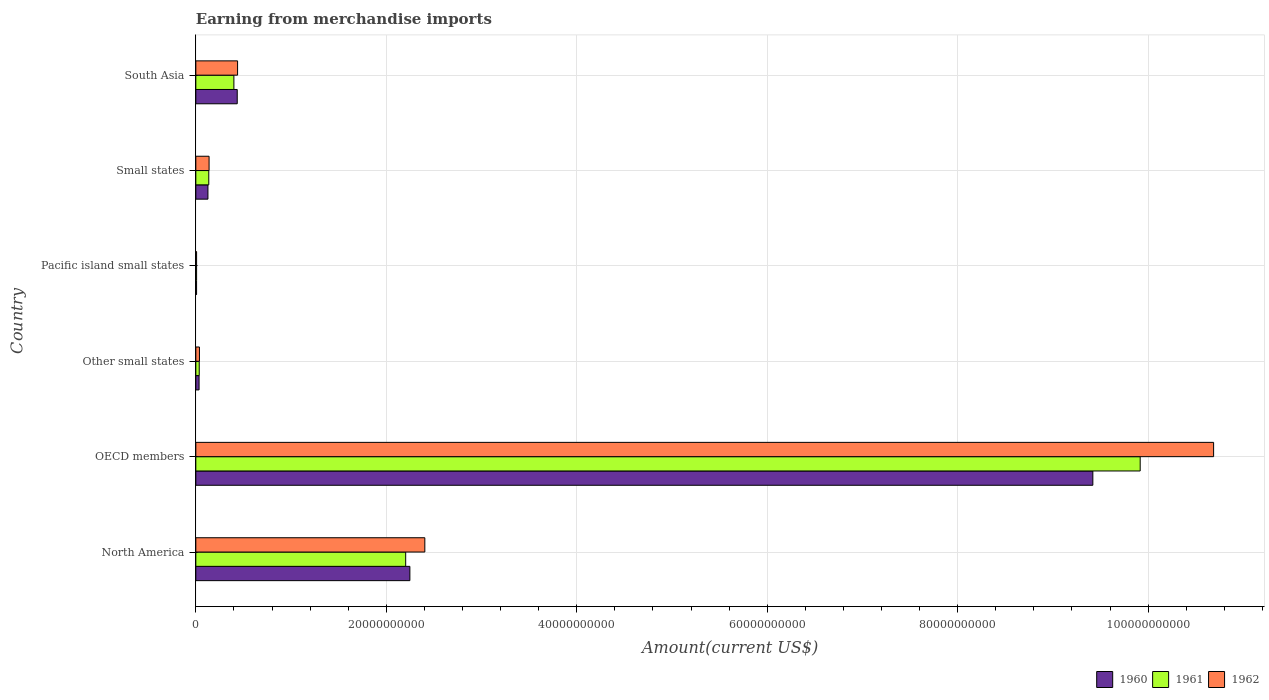How many groups of bars are there?
Keep it short and to the point. 6. Are the number of bars per tick equal to the number of legend labels?
Provide a short and direct response. Yes. How many bars are there on the 5th tick from the top?
Ensure brevity in your answer.  3. How many bars are there on the 5th tick from the bottom?
Keep it short and to the point. 3. In how many cases, is the number of bars for a given country not equal to the number of legend labels?
Offer a very short reply. 0. What is the amount earned from merchandise imports in 1961 in Other small states?
Your response must be concise. 3.58e+08. Across all countries, what is the maximum amount earned from merchandise imports in 1960?
Offer a terse response. 9.42e+1. Across all countries, what is the minimum amount earned from merchandise imports in 1961?
Ensure brevity in your answer.  8.07e+07. In which country was the amount earned from merchandise imports in 1960 minimum?
Your answer should be very brief. Pacific island small states. What is the total amount earned from merchandise imports in 1962 in the graph?
Your answer should be very brief. 1.37e+11. What is the difference between the amount earned from merchandise imports in 1961 in OECD members and that in Other small states?
Provide a succinct answer. 9.88e+1. What is the difference between the amount earned from merchandise imports in 1962 in North America and the amount earned from merchandise imports in 1960 in OECD members?
Your answer should be very brief. -7.01e+1. What is the average amount earned from merchandise imports in 1960 per country?
Ensure brevity in your answer.  2.05e+1. What is the difference between the amount earned from merchandise imports in 1962 and amount earned from merchandise imports in 1961 in North America?
Give a very brief answer. 2.01e+09. In how many countries, is the amount earned from merchandise imports in 1961 greater than 4000000000 US$?
Provide a succinct answer. 2. What is the ratio of the amount earned from merchandise imports in 1962 in Other small states to that in Pacific island small states?
Make the answer very short. 4.69. What is the difference between the highest and the second highest amount earned from merchandise imports in 1960?
Your answer should be compact. 7.17e+1. What is the difference between the highest and the lowest amount earned from merchandise imports in 1961?
Offer a terse response. 9.91e+1. What does the 3rd bar from the top in North America represents?
Your response must be concise. 1960. How many countries are there in the graph?
Your answer should be very brief. 6. What is the difference between two consecutive major ticks on the X-axis?
Your answer should be compact. 2.00e+1. Are the values on the major ticks of X-axis written in scientific E-notation?
Your answer should be compact. No. Does the graph contain any zero values?
Ensure brevity in your answer.  No. Does the graph contain grids?
Provide a succinct answer. Yes. Where does the legend appear in the graph?
Offer a terse response. Bottom right. How are the legend labels stacked?
Your answer should be very brief. Horizontal. What is the title of the graph?
Offer a terse response. Earning from merchandise imports. What is the label or title of the X-axis?
Provide a short and direct response. Amount(current US$). What is the Amount(current US$) of 1960 in North America?
Give a very brief answer. 2.25e+1. What is the Amount(current US$) in 1961 in North America?
Provide a succinct answer. 2.20e+1. What is the Amount(current US$) of 1962 in North America?
Make the answer very short. 2.40e+1. What is the Amount(current US$) of 1960 in OECD members?
Make the answer very short. 9.42e+1. What is the Amount(current US$) in 1961 in OECD members?
Your response must be concise. 9.92e+1. What is the Amount(current US$) in 1962 in OECD members?
Your response must be concise. 1.07e+11. What is the Amount(current US$) of 1960 in Other small states?
Provide a succinct answer. 3.42e+08. What is the Amount(current US$) of 1961 in Other small states?
Your answer should be very brief. 3.58e+08. What is the Amount(current US$) in 1962 in Other small states?
Provide a short and direct response. 3.80e+08. What is the Amount(current US$) in 1960 in Pacific island small states?
Give a very brief answer. 7.79e+07. What is the Amount(current US$) in 1961 in Pacific island small states?
Provide a short and direct response. 8.07e+07. What is the Amount(current US$) of 1962 in Pacific island small states?
Give a very brief answer. 8.11e+07. What is the Amount(current US$) of 1960 in Small states?
Provide a short and direct response. 1.27e+09. What is the Amount(current US$) in 1961 in Small states?
Keep it short and to the point. 1.36e+09. What is the Amount(current US$) of 1962 in Small states?
Your answer should be very brief. 1.39e+09. What is the Amount(current US$) of 1960 in South Asia?
Offer a very short reply. 4.35e+09. What is the Amount(current US$) of 1961 in South Asia?
Ensure brevity in your answer.  4.00e+09. What is the Amount(current US$) of 1962 in South Asia?
Keep it short and to the point. 4.38e+09. Across all countries, what is the maximum Amount(current US$) in 1960?
Keep it short and to the point. 9.42e+1. Across all countries, what is the maximum Amount(current US$) of 1961?
Offer a very short reply. 9.92e+1. Across all countries, what is the maximum Amount(current US$) in 1962?
Provide a succinct answer. 1.07e+11. Across all countries, what is the minimum Amount(current US$) of 1960?
Make the answer very short. 7.79e+07. Across all countries, what is the minimum Amount(current US$) of 1961?
Provide a succinct answer. 8.07e+07. Across all countries, what is the minimum Amount(current US$) of 1962?
Your response must be concise. 8.11e+07. What is the total Amount(current US$) of 1960 in the graph?
Offer a terse response. 1.23e+11. What is the total Amount(current US$) of 1961 in the graph?
Offer a very short reply. 1.27e+11. What is the total Amount(current US$) of 1962 in the graph?
Your answer should be very brief. 1.37e+11. What is the difference between the Amount(current US$) of 1960 in North America and that in OECD members?
Offer a terse response. -7.17e+1. What is the difference between the Amount(current US$) of 1961 in North America and that in OECD members?
Provide a succinct answer. -7.71e+1. What is the difference between the Amount(current US$) of 1962 in North America and that in OECD members?
Your response must be concise. -8.28e+1. What is the difference between the Amount(current US$) of 1960 in North America and that in Other small states?
Your answer should be compact. 2.21e+1. What is the difference between the Amount(current US$) in 1961 in North America and that in Other small states?
Ensure brevity in your answer.  2.17e+1. What is the difference between the Amount(current US$) of 1962 in North America and that in Other small states?
Provide a succinct answer. 2.37e+1. What is the difference between the Amount(current US$) of 1960 in North America and that in Pacific island small states?
Offer a terse response. 2.24e+1. What is the difference between the Amount(current US$) in 1961 in North America and that in Pacific island small states?
Your answer should be very brief. 2.20e+1. What is the difference between the Amount(current US$) of 1962 in North America and that in Pacific island small states?
Provide a succinct answer. 2.40e+1. What is the difference between the Amount(current US$) in 1960 in North America and that in Small states?
Your response must be concise. 2.12e+1. What is the difference between the Amount(current US$) in 1961 in North America and that in Small states?
Offer a terse response. 2.07e+1. What is the difference between the Amount(current US$) in 1962 in North America and that in Small states?
Provide a succinct answer. 2.27e+1. What is the difference between the Amount(current US$) of 1960 in North America and that in South Asia?
Provide a succinct answer. 1.81e+1. What is the difference between the Amount(current US$) of 1961 in North America and that in South Asia?
Your answer should be compact. 1.80e+1. What is the difference between the Amount(current US$) in 1962 in North America and that in South Asia?
Provide a succinct answer. 1.97e+1. What is the difference between the Amount(current US$) in 1960 in OECD members and that in Other small states?
Offer a terse response. 9.38e+1. What is the difference between the Amount(current US$) in 1961 in OECD members and that in Other small states?
Offer a very short reply. 9.88e+1. What is the difference between the Amount(current US$) in 1962 in OECD members and that in Other small states?
Ensure brevity in your answer.  1.06e+11. What is the difference between the Amount(current US$) of 1960 in OECD members and that in Pacific island small states?
Ensure brevity in your answer.  9.41e+1. What is the difference between the Amount(current US$) in 1961 in OECD members and that in Pacific island small states?
Give a very brief answer. 9.91e+1. What is the difference between the Amount(current US$) in 1962 in OECD members and that in Pacific island small states?
Offer a terse response. 1.07e+11. What is the difference between the Amount(current US$) in 1960 in OECD members and that in Small states?
Provide a short and direct response. 9.29e+1. What is the difference between the Amount(current US$) in 1961 in OECD members and that in Small states?
Offer a terse response. 9.78e+1. What is the difference between the Amount(current US$) of 1962 in OECD members and that in Small states?
Your response must be concise. 1.05e+11. What is the difference between the Amount(current US$) in 1960 in OECD members and that in South Asia?
Keep it short and to the point. 8.98e+1. What is the difference between the Amount(current US$) in 1961 in OECD members and that in South Asia?
Your answer should be very brief. 9.52e+1. What is the difference between the Amount(current US$) in 1962 in OECD members and that in South Asia?
Provide a succinct answer. 1.02e+11. What is the difference between the Amount(current US$) in 1960 in Other small states and that in Pacific island small states?
Provide a succinct answer. 2.64e+08. What is the difference between the Amount(current US$) of 1961 in Other small states and that in Pacific island small states?
Your answer should be very brief. 2.77e+08. What is the difference between the Amount(current US$) of 1962 in Other small states and that in Pacific island small states?
Keep it short and to the point. 2.99e+08. What is the difference between the Amount(current US$) of 1960 in Other small states and that in Small states?
Your answer should be very brief. -9.30e+08. What is the difference between the Amount(current US$) in 1961 in Other small states and that in Small states?
Provide a short and direct response. -1.00e+09. What is the difference between the Amount(current US$) of 1962 in Other small states and that in Small states?
Provide a succinct answer. -1.01e+09. What is the difference between the Amount(current US$) of 1960 in Other small states and that in South Asia?
Your response must be concise. -4.01e+09. What is the difference between the Amount(current US$) in 1961 in Other small states and that in South Asia?
Make the answer very short. -3.64e+09. What is the difference between the Amount(current US$) in 1962 in Other small states and that in South Asia?
Provide a succinct answer. -4.00e+09. What is the difference between the Amount(current US$) of 1960 in Pacific island small states and that in Small states?
Offer a very short reply. -1.19e+09. What is the difference between the Amount(current US$) of 1961 in Pacific island small states and that in Small states?
Your answer should be compact. -1.28e+09. What is the difference between the Amount(current US$) in 1962 in Pacific island small states and that in Small states?
Offer a terse response. -1.31e+09. What is the difference between the Amount(current US$) in 1960 in Pacific island small states and that in South Asia?
Your answer should be very brief. -4.27e+09. What is the difference between the Amount(current US$) of 1961 in Pacific island small states and that in South Asia?
Provide a succinct answer. -3.92e+09. What is the difference between the Amount(current US$) in 1962 in Pacific island small states and that in South Asia?
Your answer should be compact. -4.30e+09. What is the difference between the Amount(current US$) of 1960 in Small states and that in South Asia?
Ensure brevity in your answer.  -3.08e+09. What is the difference between the Amount(current US$) of 1961 in Small states and that in South Asia?
Offer a terse response. -2.64e+09. What is the difference between the Amount(current US$) in 1962 in Small states and that in South Asia?
Offer a terse response. -2.99e+09. What is the difference between the Amount(current US$) of 1960 in North America and the Amount(current US$) of 1961 in OECD members?
Your answer should be compact. -7.67e+1. What is the difference between the Amount(current US$) in 1960 in North America and the Amount(current US$) in 1962 in OECD members?
Give a very brief answer. -8.44e+1. What is the difference between the Amount(current US$) of 1961 in North America and the Amount(current US$) of 1962 in OECD members?
Offer a terse response. -8.48e+1. What is the difference between the Amount(current US$) in 1960 in North America and the Amount(current US$) in 1961 in Other small states?
Provide a short and direct response. 2.21e+1. What is the difference between the Amount(current US$) in 1960 in North America and the Amount(current US$) in 1962 in Other small states?
Your answer should be compact. 2.21e+1. What is the difference between the Amount(current US$) in 1961 in North America and the Amount(current US$) in 1962 in Other small states?
Give a very brief answer. 2.17e+1. What is the difference between the Amount(current US$) of 1960 in North America and the Amount(current US$) of 1961 in Pacific island small states?
Your answer should be compact. 2.24e+1. What is the difference between the Amount(current US$) in 1960 in North America and the Amount(current US$) in 1962 in Pacific island small states?
Provide a succinct answer. 2.24e+1. What is the difference between the Amount(current US$) in 1961 in North America and the Amount(current US$) in 1962 in Pacific island small states?
Your answer should be compact. 2.20e+1. What is the difference between the Amount(current US$) of 1960 in North America and the Amount(current US$) of 1961 in Small states?
Your answer should be very brief. 2.11e+1. What is the difference between the Amount(current US$) of 1960 in North America and the Amount(current US$) of 1962 in Small states?
Ensure brevity in your answer.  2.11e+1. What is the difference between the Amount(current US$) of 1961 in North America and the Amount(current US$) of 1962 in Small states?
Your answer should be compact. 2.06e+1. What is the difference between the Amount(current US$) of 1960 in North America and the Amount(current US$) of 1961 in South Asia?
Provide a short and direct response. 1.85e+1. What is the difference between the Amount(current US$) of 1960 in North America and the Amount(current US$) of 1962 in South Asia?
Offer a very short reply. 1.81e+1. What is the difference between the Amount(current US$) of 1961 in North America and the Amount(current US$) of 1962 in South Asia?
Your answer should be very brief. 1.77e+1. What is the difference between the Amount(current US$) of 1960 in OECD members and the Amount(current US$) of 1961 in Other small states?
Give a very brief answer. 9.38e+1. What is the difference between the Amount(current US$) of 1960 in OECD members and the Amount(current US$) of 1962 in Other small states?
Provide a short and direct response. 9.38e+1. What is the difference between the Amount(current US$) in 1961 in OECD members and the Amount(current US$) in 1962 in Other small states?
Ensure brevity in your answer.  9.88e+1. What is the difference between the Amount(current US$) of 1960 in OECD members and the Amount(current US$) of 1961 in Pacific island small states?
Provide a short and direct response. 9.41e+1. What is the difference between the Amount(current US$) in 1960 in OECD members and the Amount(current US$) in 1962 in Pacific island small states?
Your response must be concise. 9.41e+1. What is the difference between the Amount(current US$) of 1961 in OECD members and the Amount(current US$) of 1962 in Pacific island small states?
Offer a very short reply. 9.91e+1. What is the difference between the Amount(current US$) of 1960 in OECD members and the Amount(current US$) of 1961 in Small states?
Provide a short and direct response. 9.28e+1. What is the difference between the Amount(current US$) of 1960 in OECD members and the Amount(current US$) of 1962 in Small states?
Make the answer very short. 9.28e+1. What is the difference between the Amount(current US$) of 1961 in OECD members and the Amount(current US$) of 1962 in Small states?
Offer a terse response. 9.78e+1. What is the difference between the Amount(current US$) in 1960 in OECD members and the Amount(current US$) in 1961 in South Asia?
Your answer should be compact. 9.02e+1. What is the difference between the Amount(current US$) in 1960 in OECD members and the Amount(current US$) in 1962 in South Asia?
Keep it short and to the point. 8.98e+1. What is the difference between the Amount(current US$) of 1961 in OECD members and the Amount(current US$) of 1962 in South Asia?
Your answer should be very brief. 9.48e+1. What is the difference between the Amount(current US$) of 1960 in Other small states and the Amount(current US$) of 1961 in Pacific island small states?
Your response must be concise. 2.61e+08. What is the difference between the Amount(current US$) of 1960 in Other small states and the Amount(current US$) of 1962 in Pacific island small states?
Ensure brevity in your answer.  2.61e+08. What is the difference between the Amount(current US$) of 1961 in Other small states and the Amount(current US$) of 1962 in Pacific island small states?
Give a very brief answer. 2.77e+08. What is the difference between the Amount(current US$) in 1960 in Other small states and the Amount(current US$) in 1961 in Small states?
Your answer should be very brief. -1.02e+09. What is the difference between the Amount(current US$) in 1960 in Other small states and the Amount(current US$) in 1962 in Small states?
Your answer should be compact. -1.05e+09. What is the difference between the Amount(current US$) of 1961 in Other small states and the Amount(current US$) of 1962 in Small states?
Ensure brevity in your answer.  -1.03e+09. What is the difference between the Amount(current US$) of 1960 in Other small states and the Amount(current US$) of 1961 in South Asia?
Offer a very short reply. -3.65e+09. What is the difference between the Amount(current US$) of 1960 in Other small states and the Amount(current US$) of 1962 in South Asia?
Provide a short and direct response. -4.04e+09. What is the difference between the Amount(current US$) in 1961 in Other small states and the Amount(current US$) in 1962 in South Asia?
Give a very brief answer. -4.03e+09. What is the difference between the Amount(current US$) of 1960 in Pacific island small states and the Amount(current US$) of 1961 in Small states?
Provide a succinct answer. -1.28e+09. What is the difference between the Amount(current US$) in 1960 in Pacific island small states and the Amount(current US$) in 1962 in Small states?
Offer a terse response. -1.31e+09. What is the difference between the Amount(current US$) in 1961 in Pacific island small states and the Amount(current US$) in 1962 in Small states?
Give a very brief answer. -1.31e+09. What is the difference between the Amount(current US$) of 1960 in Pacific island small states and the Amount(current US$) of 1961 in South Asia?
Keep it short and to the point. -3.92e+09. What is the difference between the Amount(current US$) of 1960 in Pacific island small states and the Amount(current US$) of 1962 in South Asia?
Provide a succinct answer. -4.31e+09. What is the difference between the Amount(current US$) of 1961 in Pacific island small states and the Amount(current US$) of 1962 in South Asia?
Your answer should be very brief. -4.30e+09. What is the difference between the Amount(current US$) in 1960 in Small states and the Amount(current US$) in 1961 in South Asia?
Ensure brevity in your answer.  -2.72e+09. What is the difference between the Amount(current US$) of 1960 in Small states and the Amount(current US$) of 1962 in South Asia?
Your answer should be compact. -3.11e+09. What is the difference between the Amount(current US$) in 1961 in Small states and the Amount(current US$) in 1962 in South Asia?
Give a very brief answer. -3.02e+09. What is the average Amount(current US$) of 1960 per country?
Your response must be concise. 2.05e+1. What is the average Amount(current US$) in 1961 per country?
Make the answer very short. 2.12e+1. What is the average Amount(current US$) of 1962 per country?
Provide a succinct answer. 2.29e+1. What is the difference between the Amount(current US$) in 1960 and Amount(current US$) in 1961 in North America?
Provide a succinct answer. 4.40e+08. What is the difference between the Amount(current US$) in 1960 and Amount(current US$) in 1962 in North America?
Keep it short and to the point. -1.57e+09. What is the difference between the Amount(current US$) of 1961 and Amount(current US$) of 1962 in North America?
Provide a succinct answer. -2.01e+09. What is the difference between the Amount(current US$) in 1960 and Amount(current US$) in 1961 in OECD members?
Ensure brevity in your answer.  -4.97e+09. What is the difference between the Amount(current US$) of 1960 and Amount(current US$) of 1962 in OECD members?
Keep it short and to the point. -1.27e+1. What is the difference between the Amount(current US$) of 1961 and Amount(current US$) of 1962 in OECD members?
Your answer should be compact. -7.71e+09. What is the difference between the Amount(current US$) of 1960 and Amount(current US$) of 1961 in Other small states?
Offer a very short reply. -1.59e+07. What is the difference between the Amount(current US$) in 1960 and Amount(current US$) in 1962 in Other small states?
Keep it short and to the point. -3.87e+07. What is the difference between the Amount(current US$) in 1961 and Amount(current US$) in 1962 in Other small states?
Ensure brevity in your answer.  -2.28e+07. What is the difference between the Amount(current US$) in 1960 and Amount(current US$) in 1961 in Pacific island small states?
Make the answer very short. -2.87e+06. What is the difference between the Amount(current US$) in 1960 and Amount(current US$) in 1962 in Pacific island small states?
Your response must be concise. -3.20e+06. What is the difference between the Amount(current US$) of 1961 and Amount(current US$) of 1962 in Pacific island small states?
Give a very brief answer. -3.35e+05. What is the difference between the Amount(current US$) of 1960 and Amount(current US$) of 1961 in Small states?
Provide a short and direct response. -8.82e+07. What is the difference between the Amount(current US$) in 1960 and Amount(current US$) in 1962 in Small states?
Offer a very short reply. -1.20e+08. What is the difference between the Amount(current US$) of 1961 and Amount(current US$) of 1962 in Small states?
Offer a very short reply. -3.18e+07. What is the difference between the Amount(current US$) in 1960 and Amount(current US$) in 1961 in South Asia?
Provide a short and direct response. 3.52e+08. What is the difference between the Amount(current US$) of 1960 and Amount(current US$) of 1962 in South Asia?
Your answer should be very brief. -3.62e+07. What is the difference between the Amount(current US$) in 1961 and Amount(current US$) in 1962 in South Asia?
Your response must be concise. -3.88e+08. What is the ratio of the Amount(current US$) in 1960 in North America to that in OECD members?
Your answer should be very brief. 0.24. What is the ratio of the Amount(current US$) in 1961 in North America to that in OECD members?
Offer a very short reply. 0.22. What is the ratio of the Amount(current US$) of 1962 in North America to that in OECD members?
Provide a short and direct response. 0.23. What is the ratio of the Amount(current US$) of 1960 in North America to that in Other small states?
Keep it short and to the point. 65.77. What is the ratio of the Amount(current US$) in 1961 in North America to that in Other small states?
Your answer should be very brief. 61.62. What is the ratio of the Amount(current US$) in 1962 in North America to that in Other small states?
Your answer should be compact. 63.2. What is the ratio of the Amount(current US$) in 1960 in North America to that in Pacific island small states?
Provide a short and direct response. 288.65. What is the ratio of the Amount(current US$) of 1961 in North America to that in Pacific island small states?
Your answer should be very brief. 272.94. What is the ratio of the Amount(current US$) in 1962 in North America to that in Pacific island small states?
Provide a short and direct response. 296.61. What is the ratio of the Amount(current US$) of 1960 in North America to that in Small states?
Ensure brevity in your answer.  17.67. What is the ratio of the Amount(current US$) in 1961 in North America to that in Small states?
Give a very brief answer. 16.2. What is the ratio of the Amount(current US$) in 1962 in North America to that in Small states?
Provide a succinct answer. 17.27. What is the ratio of the Amount(current US$) of 1960 in North America to that in South Asia?
Provide a succinct answer. 5.17. What is the ratio of the Amount(current US$) in 1961 in North America to that in South Asia?
Your answer should be very brief. 5.51. What is the ratio of the Amount(current US$) in 1962 in North America to that in South Asia?
Make the answer very short. 5.48. What is the ratio of the Amount(current US$) of 1960 in OECD members to that in Other small states?
Keep it short and to the point. 275.63. What is the ratio of the Amount(current US$) in 1961 in OECD members to that in Other small states?
Your answer should be very brief. 277.27. What is the ratio of the Amount(current US$) in 1962 in OECD members to that in Other small states?
Keep it short and to the point. 280.88. What is the ratio of the Amount(current US$) of 1960 in OECD members to that in Pacific island small states?
Your answer should be compact. 1209.63. What is the ratio of the Amount(current US$) in 1961 in OECD members to that in Pacific island small states?
Your response must be concise. 1228.24. What is the ratio of the Amount(current US$) of 1962 in OECD members to that in Pacific island small states?
Your response must be concise. 1318.27. What is the ratio of the Amount(current US$) of 1960 in OECD members to that in Small states?
Offer a terse response. 74.05. What is the ratio of the Amount(current US$) in 1961 in OECD members to that in Small states?
Provide a short and direct response. 72.9. What is the ratio of the Amount(current US$) of 1962 in OECD members to that in Small states?
Your response must be concise. 76.77. What is the ratio of the Amount(current US$) in 1960 in OECD members to that in South Asia?
Offer a terse response. 21.66. What is the ratio of the Amount(current US$) of 1961 in OECD members to that in South Asia?
Keep it short and to the point. 24.81. What is the ratio of the Amount(current US$) of 1962 in OECD members to that in South Asia?
Provide a succinct answer. 24.38. What is the ratio of the Amount(current US$) in 1960 in Other small states to that in Pacific island small states?
Make the answer very short. 4.39. What is the ratio of the Amount(current US$) in 1961 in Other small states to that in Pacific island small states?
Give a very brief answer. 4.43. What is the ratio of the Amount(current US$) of 1962 in Other small states to that in Pacific island small states?
Your answer should be compact. 4.69. What is the ratio of the Amount(current US$) in 1960 in Other small states to that in Small states?
Your answer should be compact. 0.27. What is the ratio of the Amount(current US$) of 1961 in Other small states to that in Small states?
Offer a very short reply. 0.26. What is the ratio of the Amount(current US$) of 1962 in Other small states to that in Small states?
Your answer should be very brief. 0.27. What is the ratio of the Amount(current US$) in 1960 in Other small states to that in South Asia?
Make the answer very short. 0.08. What is the ratio of the Amount(current US$) of 1961 in Other small states to that in South Asia?
Your response must be concise. 0.09. What is the ratio of the Amount(current US$) of 1962 in Other small states to that in South Asia?
Provide a short and direct response. 0.09. What is the ratio of the Amount(current US$) in 1960 in Pacific island small states to that in Small states?
Ensure brevity in your answer.  0.06. What is the ratio of the Amount(current US$) of 1961 in Pacific island small states to that in Small states?
Offer a terse response. 0.06. What is the ratio of the Amount(current US$) of 1962 in Pacific island small states to that in Small states?
Provide a succinct answer. 0.06. What is the ratio of the Amount(current US$) in 1960 in Pacific island small states to that in South Asia?
Your response must be concise. 0.02. What is the ratio of the Amount(current US$) of 1961 in Pacific island small states to that in South Asia?
Your answer should be compact. 0.02. What is the ratio of the Amount(current US$) in 1962 in Pacific island small states to that in South Asia?
Keep it short and to the point. 0.02. What is the ratio of the Amount(current US$) in 1960 in Small states to that in South Asia?
Keep it short and to the point. 0.29. What is the ratio of the Amount(current US$) of 1961 in Small states to that in South Asia?
Offer a very short reply. 0.34. What is the ratio of the Amount(current US$) of 1962 in Small states to that in South Asia?
Your response must be concise. 0.32. What is the difference between the highest and the second highest Amount(current US$) in 1960?
Offer a very short reply. 7.17e+1. What is the difference between the highest and the second highest Amount(current US$) of 1961?
Ensure brevity in your answer.  7.71e+1. What is the difference between the highest and the second highest Amount(current US$) of 1962?
Offer a very short reply. 8.28e+1. What is the difference between the highest and the lowest Amount(current US$) of 1960?
Ensure brevity in your answer.  9.41e+1. What is the difference between the highest and the lowest Amount(current US$) in 1961?
Provide a succinct answer. 9.91e+1. What is the difference between the highest and the lowest Amount(current US$) of 1962?
Provide a short and direct response. 1.07e+11. 